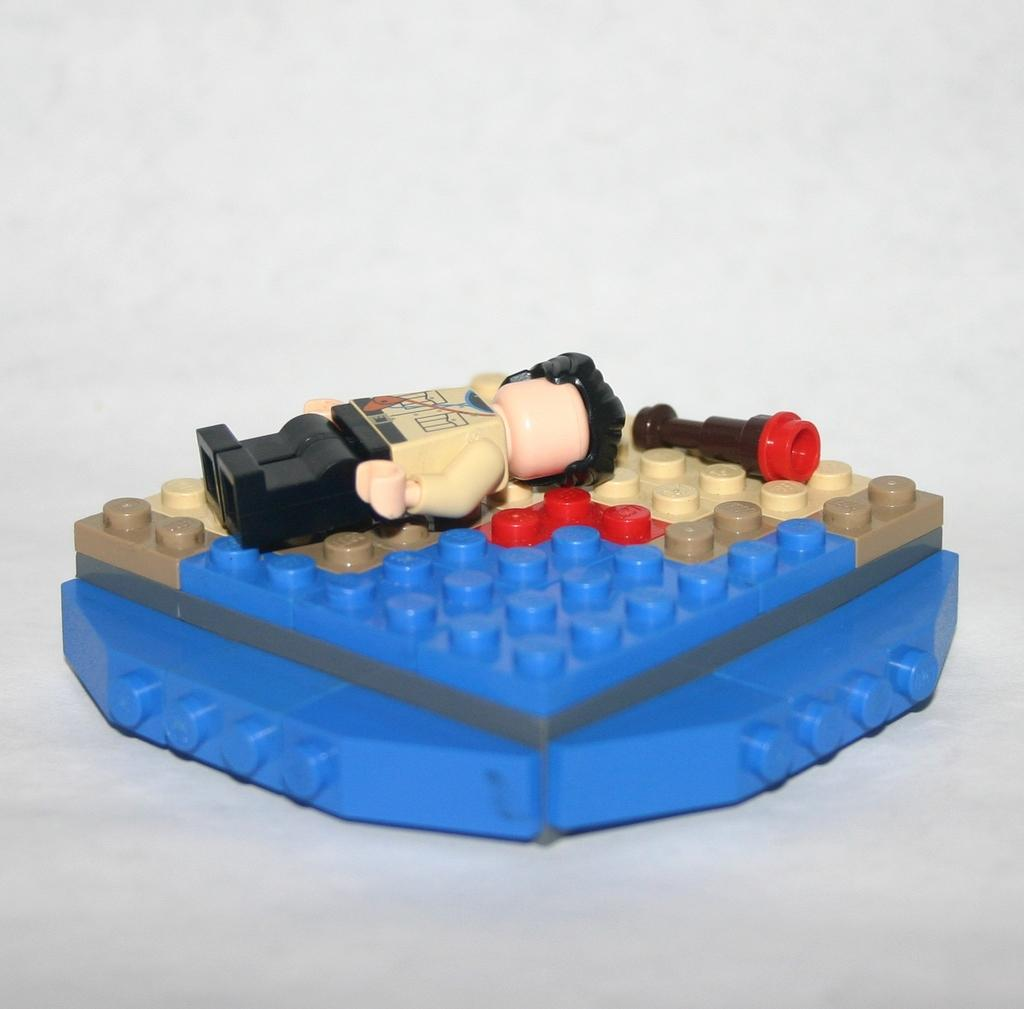What object can be seen in the image? There is a toy in the image. Where is the toy located? The toy is on a surface. What color is the background of the image? The background of the image is white in color. How many beads are attached to the toy in the image? There is no information about beads or any specific details about the toy in the image, so it is not possible to answer this question. 